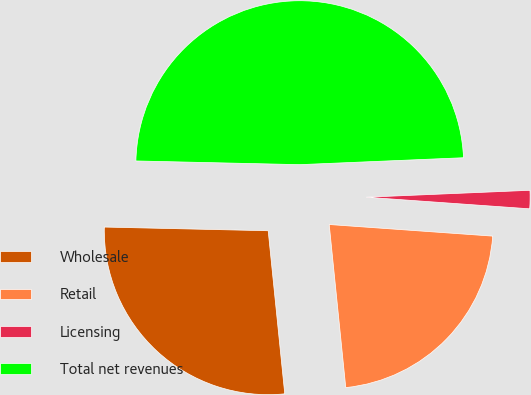Convert chart. <chart><loc_0><loc_0><loc_500><loc_500><pie_chart><fcel>Wholesale<fcel>Retail<fcel>Licensing<fcel>Total net revenues<nl><fcel>26.97%<fcel>22.26%<fcel>1.8%<fcel>48.97%<nl></chart> 